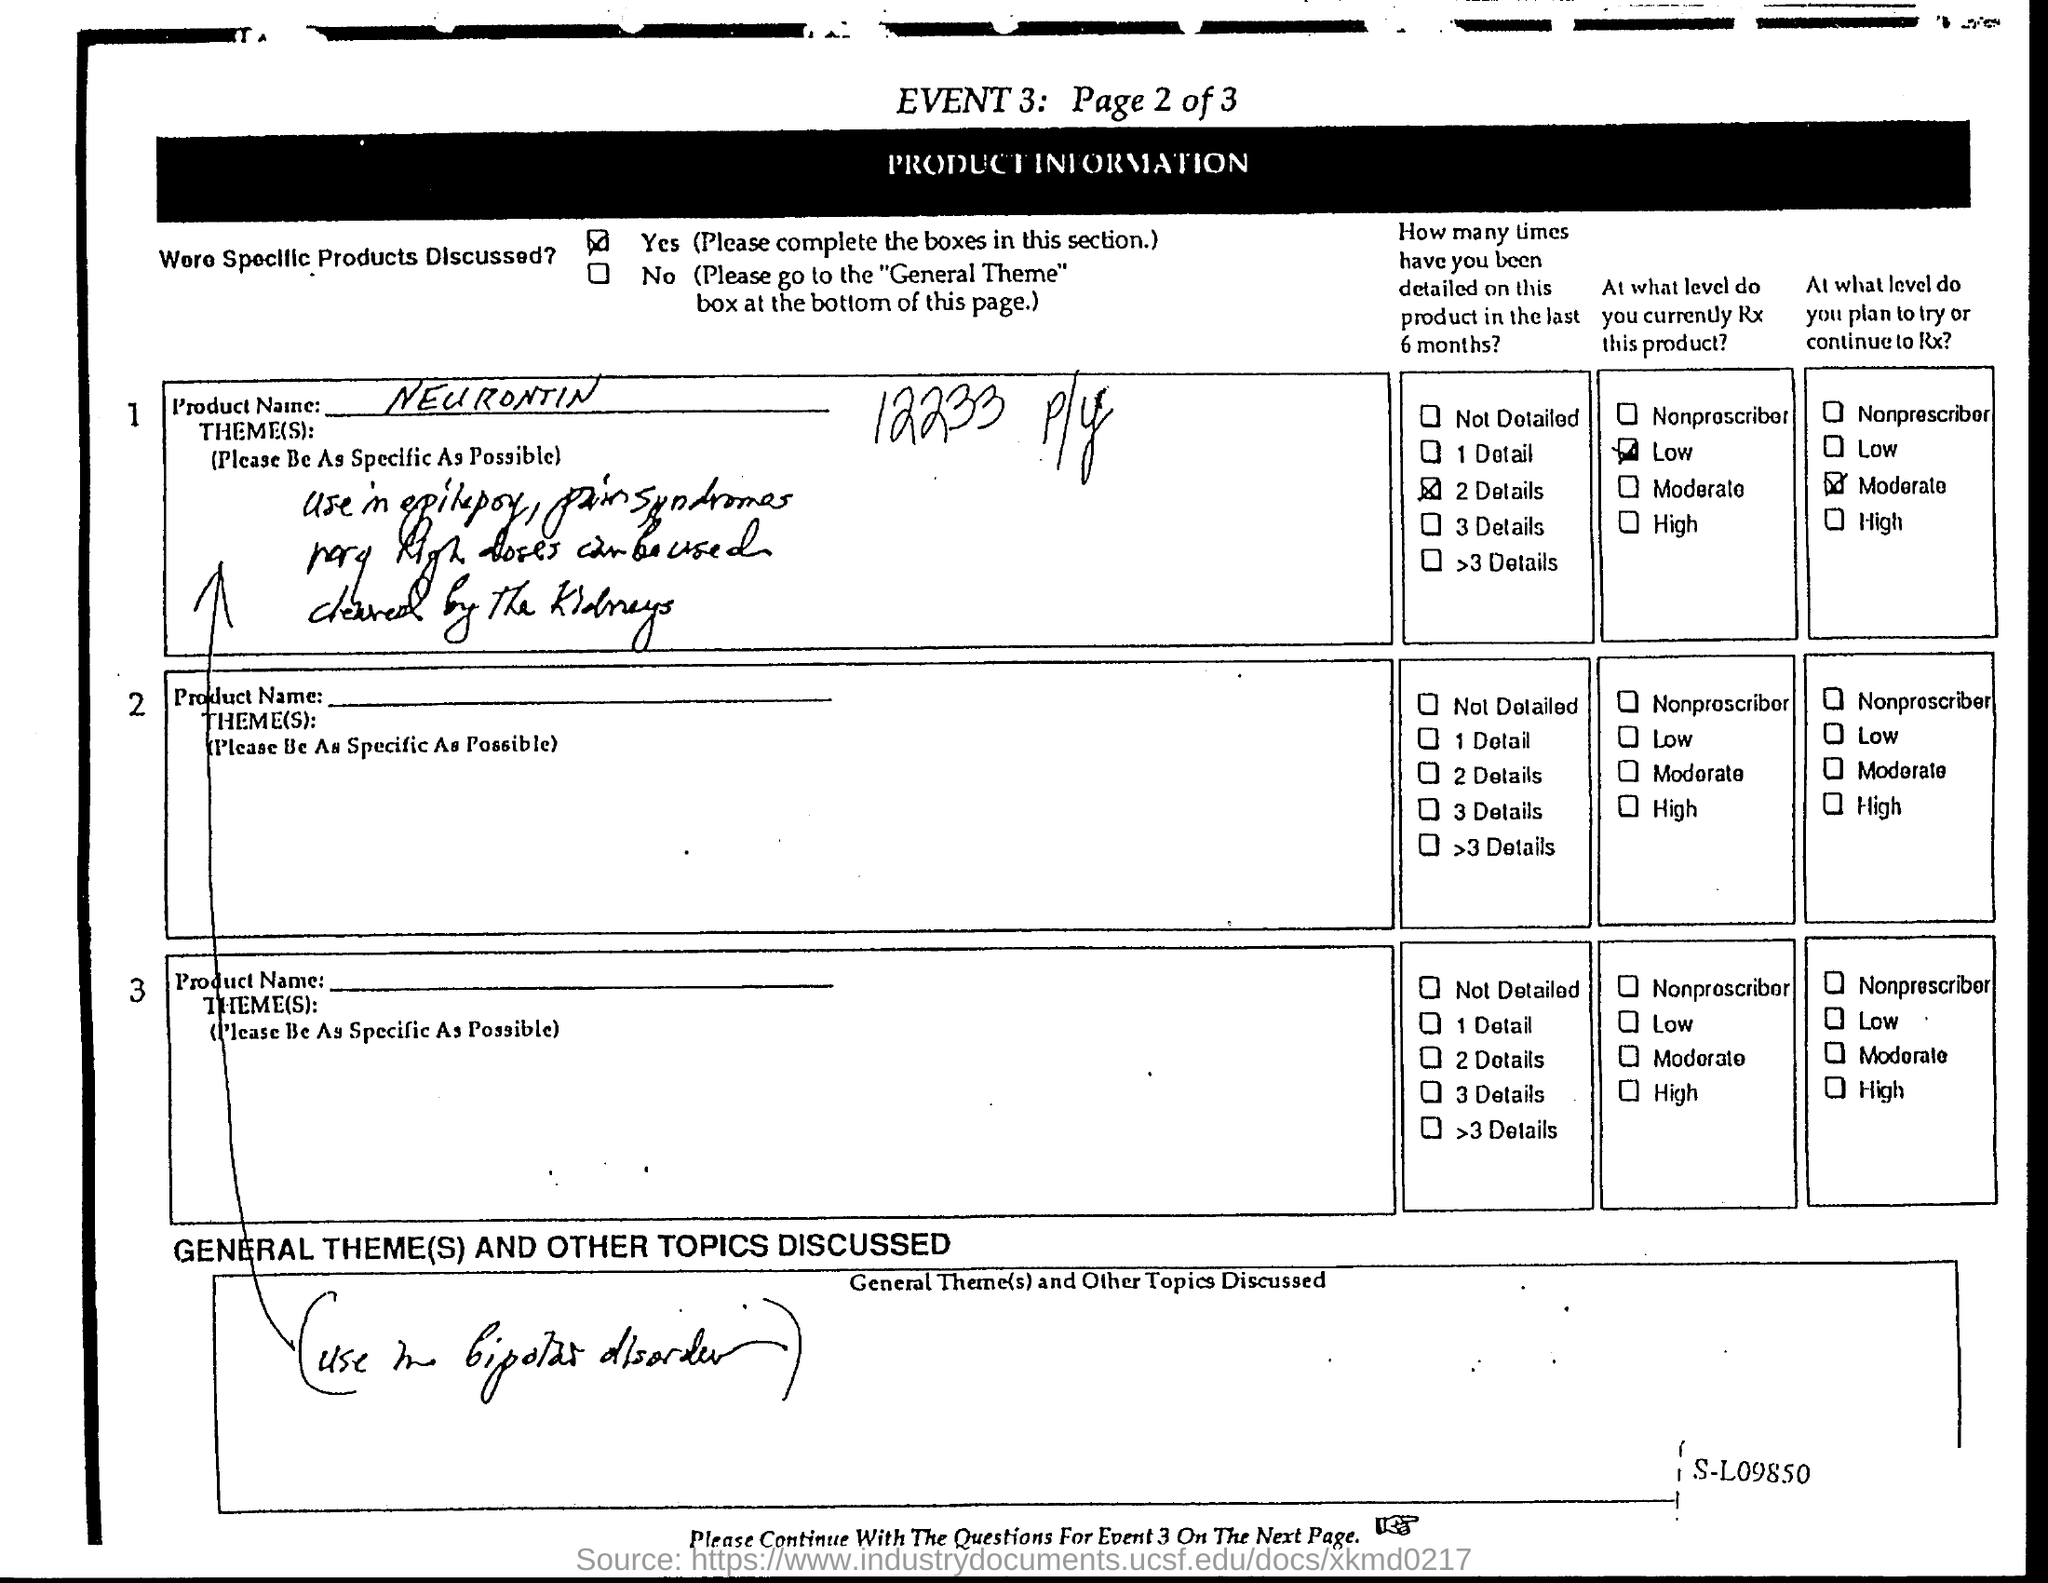What is the name of the product?
Ensure brevity in your answer.  Neurontin. 